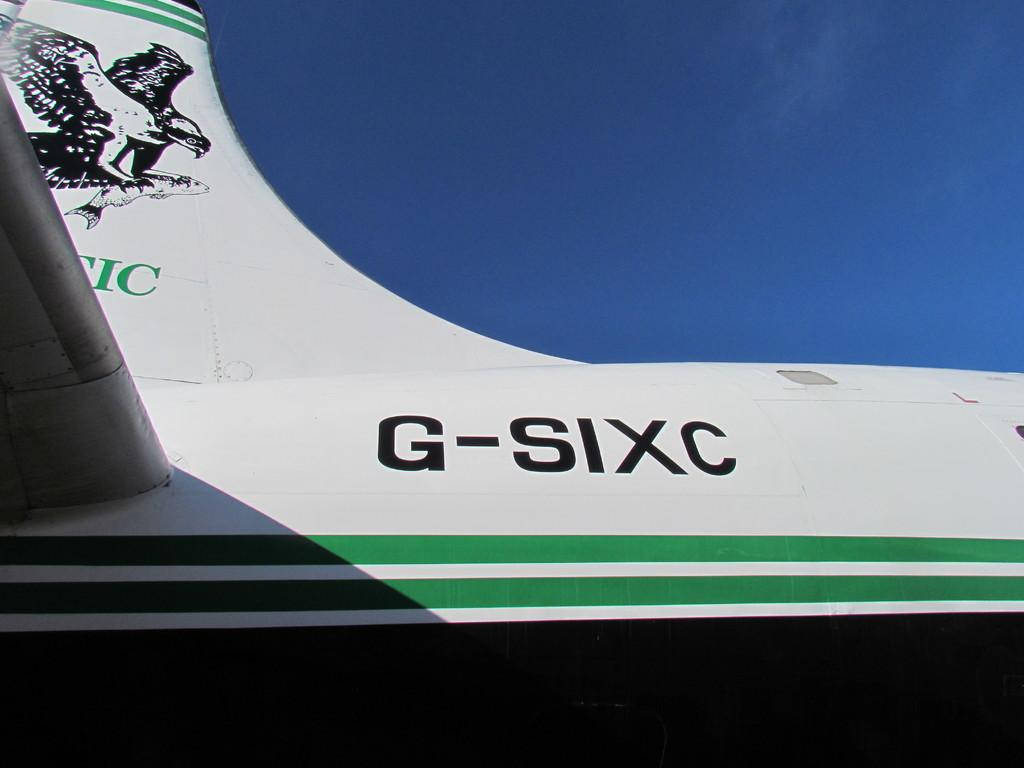<image>
Present a compact description of the photo's key features. Plane G-SIXC is white and green and has a drawing on its tail. 